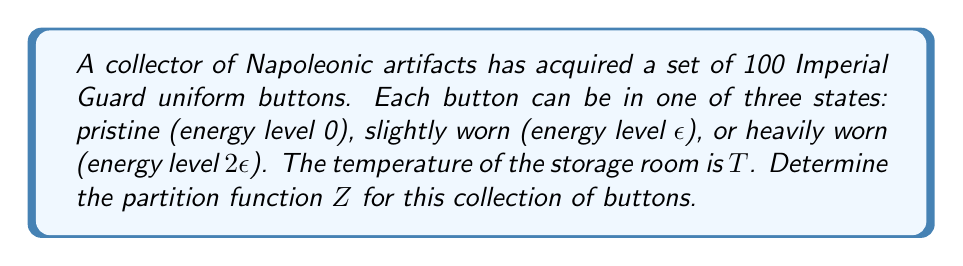Show me your answer to this math problem. 1. The partition function $Z$ for a system with discrete energy levels is given by:
   $$Z = \sum_i g_i e^{-\beta E_i}$$
   where $g_i$ is the degeneracy of each energy level, $E_i$ is the energy of each level, and $\beta = \frac{1}{k_B T}$.

2. In this case, we have three energy levels:
   - $E_1 = 0$ (pristine)
   - $E_2 = \epsilon$ (slightly worn)
   - $E_3 = 2\epsilon$ (heavily worn)

3. Each button can be in any of these three states, so we need to use the partition function for a system of independent particles:
   $$Z = (z_1)^N$$
   where $z_1$ is the partition function for a single button and $N$ is the total number of buttons.

4. The partition function for a single button is:
   $$z_1 = e^{-\beta \cdot 0} + e^{-\beta \epsilon} + e^{-\beta 2\epsilon} = 1 + e^{-\beta \epsilon} + e^{-\beta 2\epsilon}$$

5. Now, we can write the full partition function:
   $$Z = (1 + e^{-\beta \epsilon} + e^{-\beta 2\epsilon})^{100}$$

6. This expression represents the partition function for the collection of 100 Imperial Guard uniform buttons.
Answer: $Z = (1 + e^{-\beta \epsilon} + e^{-\beta 2\epsilon})^{100}$ 